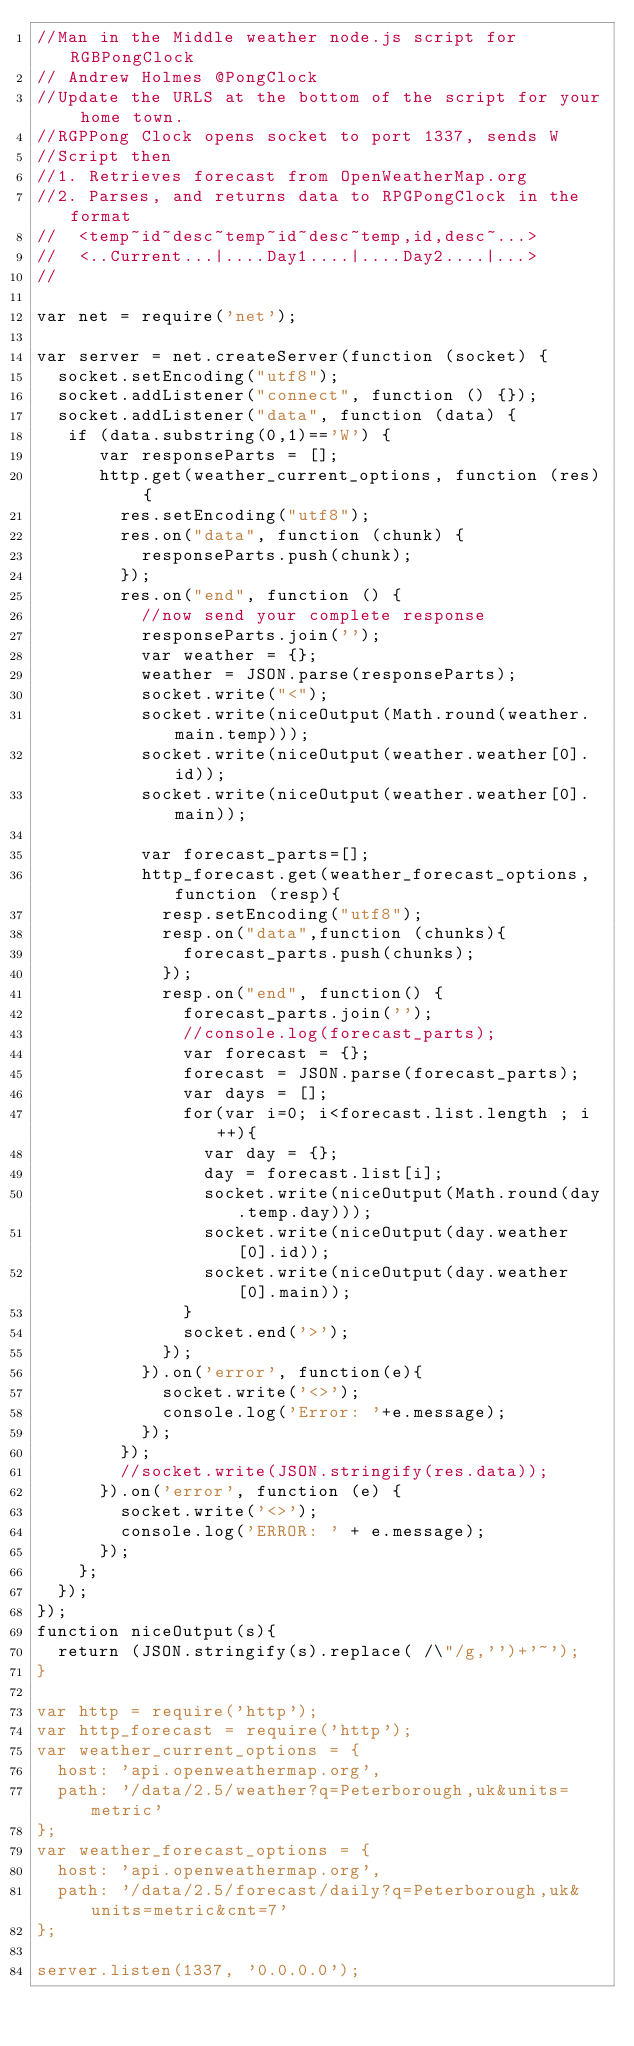<code> <loc_0><loc_0><loc_500><loc_500><_JavaScript_>//Man in the Middle weather node.js script for RGBPongClock
// Andrew Holmes @PongClock
//Update the URLS at the bottom of the script for your home town.
//RGPPong Clock opens socket to port 1337, sends W
//Script then
//1. Retrieves forecast from OpenWeatherMap.org 
//2. Parses, and returns data to RPGPongClock in the format
//  <temp~id~desc~temp~id~desc~temp,id,desc~...>
//  <..Current...|....Day1....|....Day2....|...>
//

var net = require('net');

var server = net.createServer(function (socket) {
  socket.setEncoding("utf8");
  socket.addListener("connect", function () {});
  socket.addListener("data", function (data) {
   if (data.substring(0,1)=='W') {
      var responseParts = [];
      http.get(weather_current_options, function (res) {
        res.setEncoding("utf8");
        res.on("data", function (chunk) {
          responseParts.push(chunk);
        });
        res.on("end", function () {
          //now send your complete response
          responseParts.join('');
          var weather = {};
          weather = JSON.parse(responseParts);
          socket.write("<");
          socket.write(niceOutput(Math.round(weather.main.temp)));
          socket.write(niceOutput(weather.weather[0].id));
          socket.write(niceOutput(weather.weather[0].main));

          var forecast_parts=[];
          http_forecast.get(weather_forecast_options, function (resp){
            resp.setEncoding("utf8");
            resp.on("data",function (chunks){
              forecast_parts.push(chunks);
            });
            resp.on("end", function() {
              forecast_parts.join('');
              //console.log(forecast_parts);
              var forecast = {};
              forecast = JSON.parse(forecast_parts);
              var days = [];
              for(var i=0; i<forecast.list.length ; i++){
                var day = {};
                day = forecast.list[i];
                socket.write(niceOutput(Math.round(day.temp.day)));
                socket.write(niceOutput(day.weather[0].id));
                socket.write(niceOutput(day.weather[0].main));
              }
              socket.end('>');
            });
          }).on('error', function(e){
            socket.write('<>');
            console.log('Error: '+e.message);
          });
        });
        //socket.write(JSON.stringify(res.data));
      }).on('error', function (e) {
        socket.write('<>');
        console.log('ERROR: ' + e.message);
      });
    };
  });
});
function niceOutput(s){
  return (JSON.stringify(s).replace( /\"/g,'')+'~');
}

var http = require('http');
var http_forecast = require('http');
var weather_current_options = {
  host: 'api.openweathermap.org',
  path: '/data/2.5/weather?q=Peterborough,uk&units=metric'
};
var weather_forecast_options = {
  host: 'api.openweathermap.org',
  path: '/data/2.5/forecast/daily?q=Peterborough,uk&units=metric&cnt=7'
};

server.listen(1337, '0.0.0.0');
</code> 